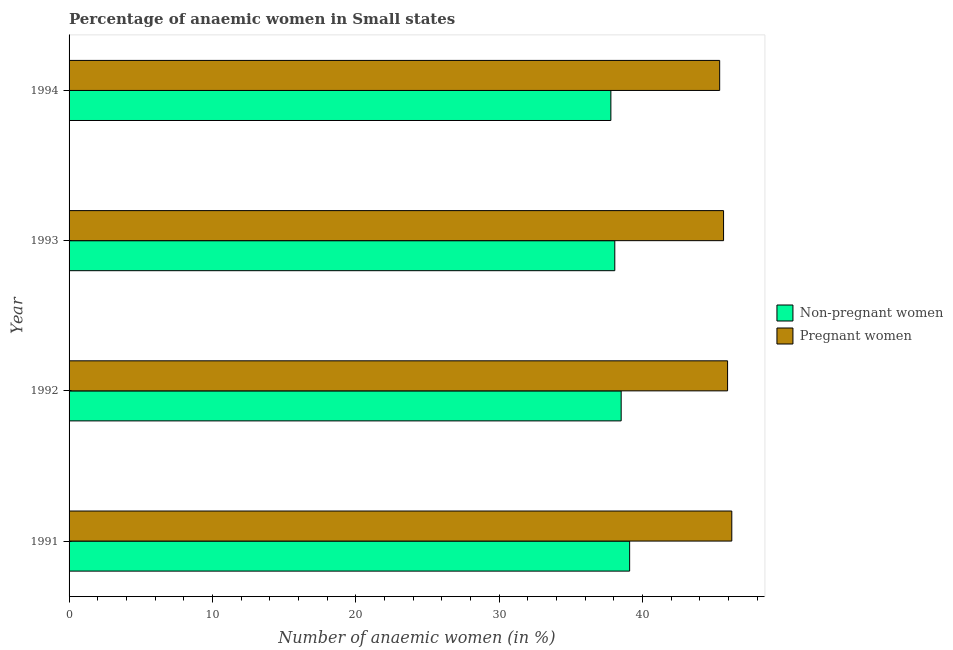Are the number of bars per tick equal to the number of legend labels?
Provide a succinct answer. Yes. Are the number of bars on each tick of the Y-axis equal?
Ensure brevity in your answer.  Yes. What is the label of the 3rd group of bars from the top?
Provide a succinct answer. 1992. In how many cases, is the number of bars for a given year not equal to the number of legend labels?
Your response must be concise. 0. What is the percentage of non-pregnant anaemic women in 1993?
Your response must be concise. 38.06. Across all years, what is the maximum percentage of pregnant anaemic women?
Your response must be concise. 46.22. Across all years, what is the minimum percentage of pregnant anaemic women?
Provide a succinct answer. 45.38. In which year was the percentage of non-pregnant anaemic women minimum?
Give a very brief answer. 1994. What is the total percentage of non-pregnant anaemic women in the graph?
Give a very brief answer. 153.45. What is the difference between the percentage of non-pregnant anaemic women in 1993 and that in 1994?
Give a very brief answer. 0.27. What is the difference between the percentage of pregnant anaemic women in 1992 and the percentage of non-pregnant anaemic women in 1991?
Offer a very short reply. 6.83. What is the average percentage of pregnant anaemic women per year?
Offer a very short reply. 45.79. In the year 1992, what is the difference between the percentage of pregnant anaemic women and percentage of non-pregnant anaemic women?
Provide a succinct answer. 7.42. In how many years, is the percentage of pregnant anaemic women greater than 28 %?
Offer a terse response. 4. What is the ratio of the percentage of non-pregnant anaemic women in 1991 to that in 1992?
Your response must be concise. 1.01. Is the difference between the percentage of non-pregnant anaemic women in 1992 and 1994 greater than the difference between the percentage of pregnant anaemic women in 1992 and 1994?
Provide a succinct answer. Yes. What is the difference between the highest and the second highest percentage of non-pregnant anaemic women?
Make the answer very short. 0.59. In how many years, is the percentage of pregnant anaemic women greater than the average percentage of pregnant anaemic women taken over all years?
Offer a very short reply. 2. What does the 2nd bar from the top in 1992 represents?
Your response must be concise. Non-pregnant women. What does the 2nd bar from the bottom in 1992 represents?
Provide a succinct answer. Pregnant women. Are all the bars in the graph horizontal?
Make the answer very short. Yes. Are the values on the major ticks of X-axis written in scientific E-notation?
Provide a short and direct response. No. Does the graph contain any zero values?
Make the answer very short. No. Does the graph contain grids?
Make the answer very short. No. Where does the legend appear in the graph?
Your answer should be very brief. Center right. What is the title of the graph?
Provide a succinct answer. Percentage of anaemic women in Small states. What is the label or title of the X-axis?
Offer a very short reply. Number of anaemic women (in %). What is the label or title of the Y-axis?
Offer a terse response. Year. What is the Number of anaemic women (in %) of Non-pregnant women in 1991?
Give a very brief answer. 39.1. What is the Number of anaemic women (in %) of Pregnant women in 1991?
Provide a short and direct response. 46.22. What is the Number of anaemic women (in %) of Non-pregnant women in 1992?
Offer a terse response. 38.51. What is the Number of anaemic women (in %) in Pregnant women in 1992?
Provide a short and direct response. 45.93. What is the Number of anaemic women (in %) of Non-pregnant women in 1993?
Your answer should be very brief. 38.06. What is the Number of anaemic women (in %) in Pregnant women in 1993?
Your answer should be very brief. 45.65. What is the Number of anaemic women (in %) of Non-pregnant women in 1994?
Offer a very short reply. 37.79. What is the Number of anaemic women (in %) in Pregnant women in 1994?
Offer a terse response. 45.38. Across all years, what is the maximum Number of anaemic women (in %) of Non-pregnant women?
Ensure brevity in your answer.  39.1. Across all years, what is the maximum Number of anaemic women (in %) in Pregnant women?
Provide a succinct answer. 46.22. Across all years, what is the minimum Number of anaemic women (in %) in Non-pregnant women?
Provide a short and direct response. 37.79. Across all years, what is the minimum Number of anaemic women (in %) in Pregnant women?
Ensure brevity in your answer.  45.38. What is the total Number of anaemic women (in %) in Non-pregnant women in the graph?
Your answer should be compact. 153.45. What is the total Number of anaemic women (in %) of Pregnant women in the graph?
Provide a short and direct response. 183.17. What is the difference between the Number of anaemic women (in %) of Non-pregnant women in 1991 and that in 1992?
Your answer should be compact. 0.59. What is the difference between the Number of anaemic women (in %) of Pregnant women in 1991 and that in 1992?
Your answer should be compact. 0.29. What is the difference between the Number of anaemic women (in %) in Non-pregnant women in 1991 and that in 1993?
Provide a succinct answer. 1.03. What is the difference between the Number of anaemic women (in %) of Pregnant women in 1991 and that in 1993?
Provide a succinct answer. 0.57. What is the difference between the Number of anaemic women (in %) in Non-pregnant women in 1991 and that in 1994?
Offer a terse response. 1.31. What is the difference between the Number of anaemic women (in %) in Pregnant women in 1991 and that in 1994?
Your answer should be compact. 0.85. What is the difference between the Number of anaemic women (in %) of Non-pregnant women in 1992 and that in 1993?
Offer a terse response. 0.45. What is the difference between the Number of anaemic women (in %) of Pregnant women in 1992 and that in 1993?
Offer a very short reply. 0.28. What is the difference between the Number of anaemic women (in %) of Non-pregnant women in 1992 and that in 1994?
Ensure brevity in your answer.  0.72. What is the difference between the Number of anaemic women (in %) in Pregnant women in 1992 and that in 1994?
Give a very brief answer. 0.55. What is the difference between the Number of anaemic women (in %) of Non-pregnant women in 1993 and that in 1994?
Offer a terse response. 0.27. What is the difference between the Number of anaemic women (in %) of Pregnant women in 1993 and that in 1994?
Keep it short and to the point. 0.27. What is the difference between the Number of anaemic women (in %) in Non-pregnant women in 1991 and the Number of anaemic women (in %) in Pregnant women in 1992?
Give a very brief answer. -6.83. What is the difference between the Number of anaemic women (in %) of Non-pregnant women in 1991 and the Number of anaemic women (in %) of Pregnant women in 1993?
Your response must be concise. -6.55. What is the difference between the Number of anaemic women (in %) in Non-pregnant women in 1991 and the Number of anaemic women (in %) in Pregnant women in 1994?
Offer a very short reply. -6.28. What is the difference between the Number of anaemic women (in %) in Non-pregnant women in 1992 and the Number of anaemic women (in %) in Pregnant women in 1993?
Your response must be concise. -7.14. What is the difference between the Number of anaemic women (in %) in Non-pregnant women in 1992 and the Number of anaemic women (in %) in Pregnant women in 1994?
Give a very brief answer. -6.87. What is the difference between the Number of anaemic women (in %) of Non-pregnant women in 1993 and the Number of anaemic women (in %) of Pregnant women in 1994?
Your answer should be very brief. -7.32. What is the average Number of anaemic women (in %) of Non-pregnant women per year?
Your answer should be very brief. 38.36. What is the average Number of anaemic women (in %) in Pregnant women per year?
Ensure brevity in your answer.  45.79. In the year 1991, what is the difference between the Number of anaemic women (in %) of Non-pregnant women and Number of anaemic women (in %) of Pregnant women?
Provide a short and direct response. -7.13. In the year 1992, what is the difference between the Number of anaemic women (in %) of Non-pregnant women and Number of anaemic women (in %) of Pregnant women?
Give a very brief answer. -7.42. In the year 1993, what is the difference between the Number of anaemic women (in %) in Non-pregnant women and Number of anaemic women (in %) in Pregnant women?
Offer a very short reply. -7.59. In the year 1994, what is the difference between the Number of anaemic women (in %) in Non-pregnant women and Number of anaemic women (in %) in Pregnant women?
Your response must be concise. -7.59. What is the ratio of the Number of anaemic women (in %) in Non-pregnant women in 1991 to that in 1992?
Your answer should be very brief. 1.02. What is the ratio of the Number of anaemic women (in %) in Pregnant women in 1991 to that in 1992?
Provide a succinct answer. 1.01. What is the ratio of the Number of anaemic women (in %) in Non-pregnant women in 1991 to that in 1993?
Make the answer very short. 1.03. What is the ratio of the Number of anaemic women (in %) of Pregnant women in 1991 to that in 1993?
Ensure brevity in your answer.  1.01. What is the ratio of the Number of anaemic women (in %) of Non-pregnant women in 1991 to that in 1994?
Offer a very short reply. 1.03. What is the ratio of the Number of anaemic women (in %) of Pregnant women in 1991 to that in 1994?
Your answer should be compact. 1.02. What is the ratio of the Number of anaemic women (in %) of Non-pregnant women in 1992 to that in 1993?
Ensure brevity in your answer.  1.01. What is the ratio of the Number of anaemic women (in %) of Pregnant women in 1992 to that in 1993?
Offer a very short reply. 1.01. What is the ratio of the Number of anaemic women (in %) of Pregnant women in 1992 to that in 1994?
Offer a terse response. 1.01. What is the ratio of the Number of anaemic women (in %) of Pregnant women in 1993 to that in 1994?
Your answer should be very brief. 1.01. What is the difference between the highest and the second highest Number of anaemic women (in %) in Non-pregnant women?
Give a very brief answer. 0.59. What is the difference between the highest and the second highest Number of anaemic women (in %) of Pregnant women?
Offer a very short reply. 0.29. What is the difference between the highest and the lowest Number of anaemic women (in %) in Non-pregnant women?
Provide a short and direct response. 1.31. What is the difference between the highest and the lowest Number of anaemic women (in %) in Pregnant women?
Your answer should be very brief. 0.85. 